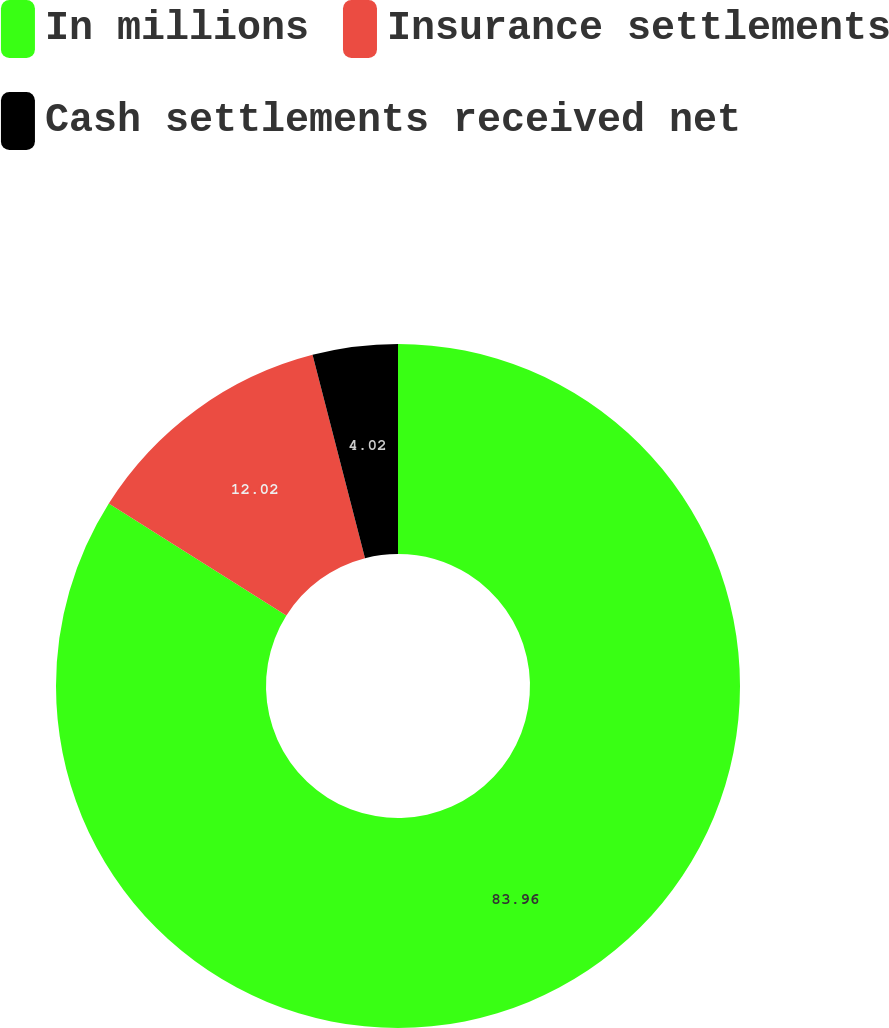Convert chart to OTSL. <chart><loc_0><loc_0><loc_500><loc_500><pie_chart><fcel>In millions<fcel>Insurance settlements<fcel>Cash settlements received net<nl><fcel>83.96%<fcel>12.02%<fcel>4.02%<nl></chart> 